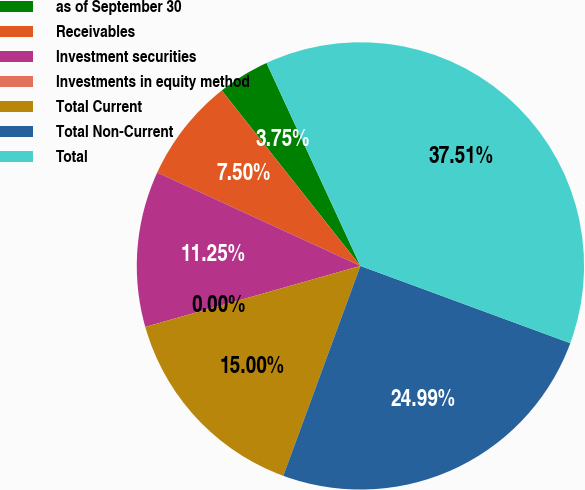Convert chart. <chart><loc_0><loc_0><loc_500><loc_500><pie_chart><fcel>as of September 30<fcel>Receivables<fcel>Investment securities<fcel>Investments in equity method<fcel>Total Current<fcel>Total Non-Current<fcel>Total<nl><fcel>3.75%<fcel>7.5%<fcel>11.25%<fcel>0.0%<fcel>15.0%<fcel>24.99%<fcel>37.51%<nl></chart> 